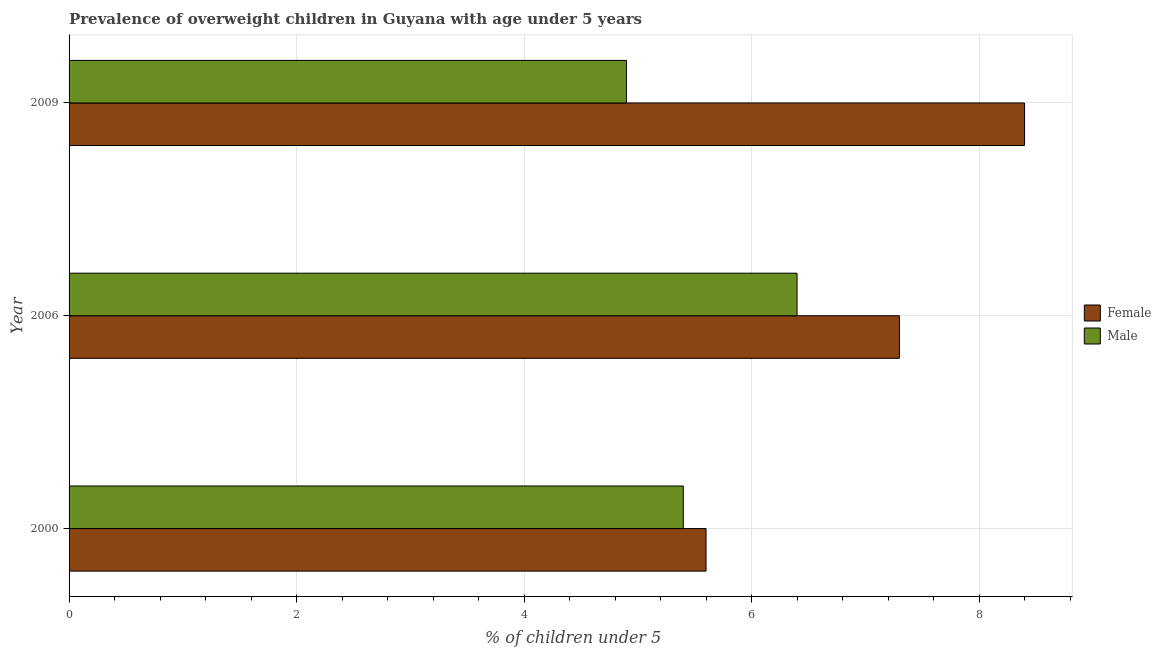How many bars are there on the 2nd tick from the bottom?
Ensure brevity in your answer.  2. What is the percentage of obese female children in 2000?
Your answer should be very brief. 5.6. Across all years, what is the maximum percentage of obese female children?
Your answer should be compact. 8.4. Across all years, what is the minimum percentage of obese male children?
Provide a succinct answer. 4.9. In which year was the percentage of obese male children maximum?
Offer a terse response. 2006. In which year was the percentage of obese male children minimum?
Your answer should be very brief. 2009. What is the total percentage of obese male children in the graph?
Ensure brevity in your answer.  16.7. What is the difference between the percentage of obese male children in 2000 and the percentage of obese female children in 2006?
Make the answer very short. -1.9. What is the average percentage of obese male children per year?
Provide a succinct answer. 5.57. In the year 2006, what is the difference between the percentage of obese male children and percentage of obese female children?
Offer a terse response. -0.9. What is the ratio of the percentage of obese female children in 2006 to that in 2009?
Provide a succinct answer. 0.87. In how many years, is the percentage of obese male children greater than the average percentage of obese male children taken over all years?
Provide a succinct answer. 1. What does the 1st bar from the top in 2009 represents?
Ensure brevity in your answer.  Male. What does the 1st bar from the bottom in 2000 represents?
Offer a terse response. Female. Are all the bars in the graph horizontal?
Keep it short and to the point. Yes. How many years are there in the graph?
Give a very brief answer. 3. What is the difference between two consecutive major ticks on the X-axis?
Give a very brief answer. 2. Does the graph contain any zero values?
Give a very brief answer. No. Does the graph contain grids?
Provide a short and direct response. Yes. Where does the legend appear in the graph?
Your response must be concise. Center right. How are the legend labels stacked?
Ensure brevity in your answer.  Vertical. What is the title of the graph?
Offer a very short reply. Prevalence of overweight children in Guyana with age under 5 years. What is the label or title of the X-axis?
Make the answer very short.  % of children under 5. What is the label or title of the Y-axis?
Your answer should be very brief. Year. What is the  % of children under 5 of Female in 2000?
Your answer should be very brief. 5.6. What is the  % of children under 5 in Male in 2000?
Make the answer very short. 5.4. What is the  % of children under 5 in Female in 2006?
Provide a succinct answer. 7.3. What is the  % of children under 5 of Male in 2006?
Ensure brevity in your answer.  6.4. What is the  % of children under 5 of Female in 2009?
Make the answer very short. 8.4. What is the  % of children under 5 in Male in 2009?
Your answer should be compact. 4.9. Across all years, what is the maximum  % of children under 5 of Female?
Make the answer very short. 8.4. Across all years, what is the maximum  % of children under 5 in Male?
Provide a succinct answer. 6.4. Across all years, what is the minimum  % of children under 5 of Female?
Offer a terse response. 5.6. Across all years, what is the minimum  % of children under 5 in Male?
Your answer should be very brief. 4.9. What is the total  % of children under 5 in Female in the graph?
Offer a terse response. 21.3. What is the total  % of children under 5 of Male in the graph?
Offer a very short reply. 16.7. What is the difference between the  % of children under 5 of Female in 2000 and that in 2006?
Make the answer very short. -1.7. What is the difference between the  % of children under 5 of Male in 2000 and that in 2009?
Your answer should be very brief. 0.5. What is the difference between the  % of children under 5 of Female in 2006 and that in 2009?
Make the answer very short. -1.1. What is the difference between the  % of children under 5 in Male in 2006 and that in 2009?
Keep it short and to the point. 1.5. What is the difference between the  % of children under 5 in Female in 2000 and the  % of children under 5 in Male in 2006?
Make the answer very short. -0.8. What is the difference between the  % of children under 5 in Female in 2006 and the  % of children under 5 in Male in 2009?
Offer a very short reply. 2.4. What is the average  % of children under 5 in Female per year?
Offer a terse response. 7.1. What is the average  % of children under 5 of Male per year?
Give a very brief answer. 5.57. What is the ratio of the  % of children under 5 of Female in 2000 to that in 2006?
Your answer should be very brief. 0.77. What is the ratio of the  % of children under 5 in Male in 2000 to that in 2006?
Give a very brief answer. 0.84. What is the ratio of the  % of children under 5 of Female in 2000 to that in 2009?
Give a very brief answer. 0.67. What is the ratio of the  % of children under 5 in Male in 2000 to that in 2009?
Ensure brevity in your answer.  1.1. What is the ratio of the  % of children under 5 in Female in 2006 to that in 2009?
Give a very brief answer. 0.87. What is the ratio of the  % of children under 5 in Male in 2006 to that in 2009?
Your response must be concise. 1.31. What is the difference between the highest and the second highest  % of children under 5 of Male?
Provide a short and direct response. 1. 